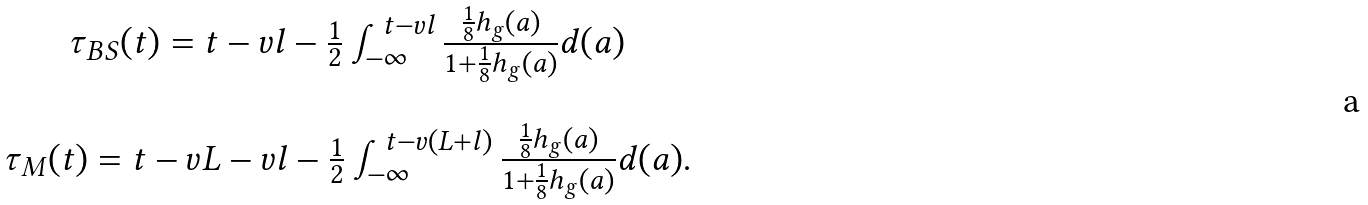Convert formula to latex. <formula><loc_0><loc_0><loc_500><loc_500>\begin{array} { c } \tau _ { B S } ( t ) = t - v l - \frac { 1 } { 2 } \int _ { - \infty } ^ { t - v l } \frac { \frac { 1 } { 8 } h _ { g } ( a ) } { 1 + \frac { 1 } { 8 } h _ { g } ( a ) } d ( a ) \\ \\ \tau _ { M } ( t ) = t - v L - v l - \frac { 1 } { 2 } \int _ { - \infty } ^ { t - v ( L + l ) } \frac { \frac { 1 } { 8 } h _ { g } ( a ) } { 1 + \frac { 1 } { 8 } h _ { g } ( a ) } d ( a ) . \end{array}</formula> 